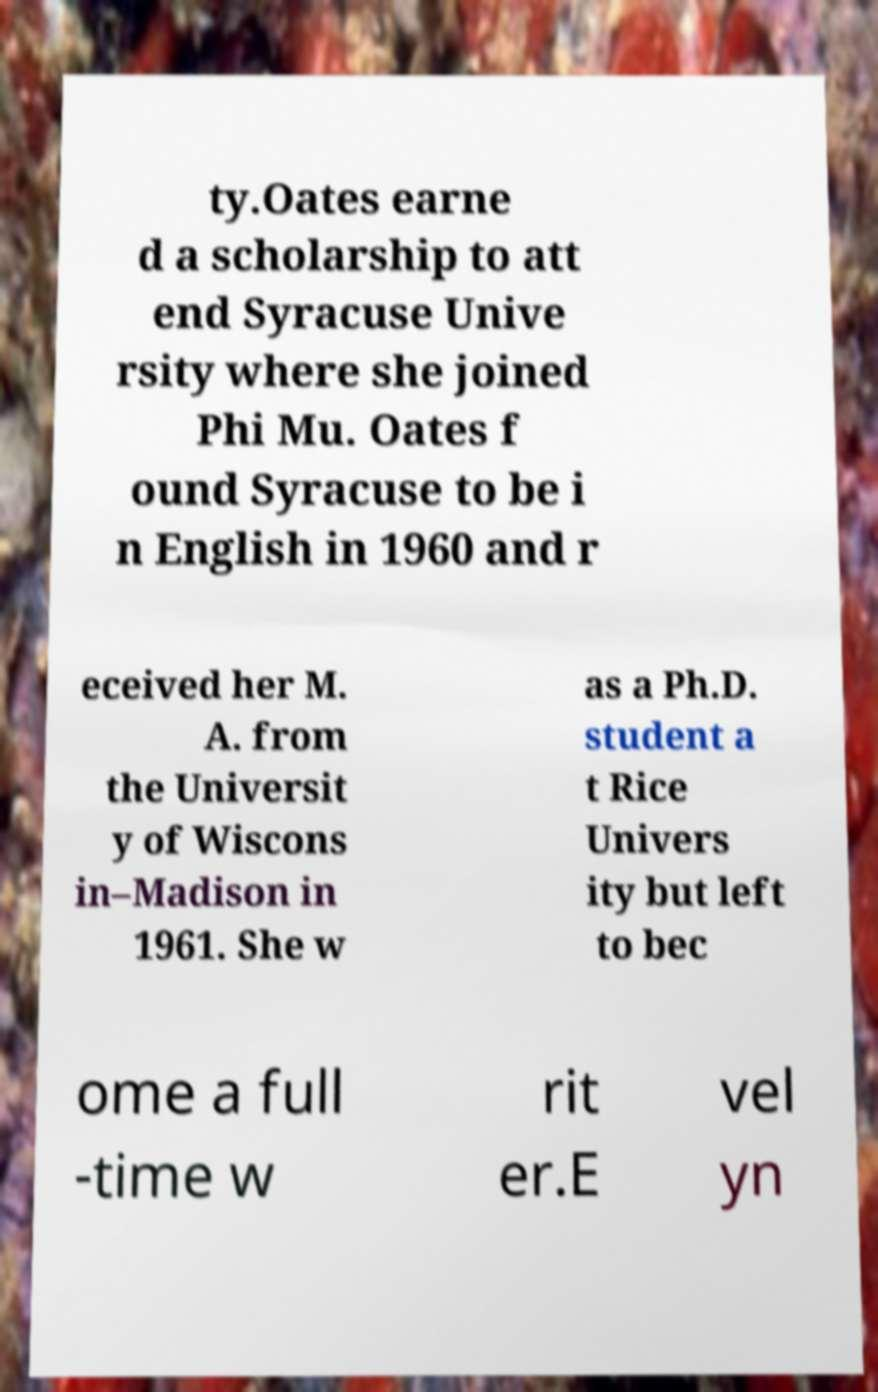Can you accurately transcribe the text from the provided image for me? ty.Oates earne d a scholarship to att end Syracuse Unive rsity where she joined Phi Mu. Oates f ound Syracuse to be i n English in 1960 and r eceived her M. A. from the Universit y of Wiscons in–Madison in 1961. She w as a Ph.D. student a t Rice Univers ity but left to bec ome a full -time w rit er.E vel yn 